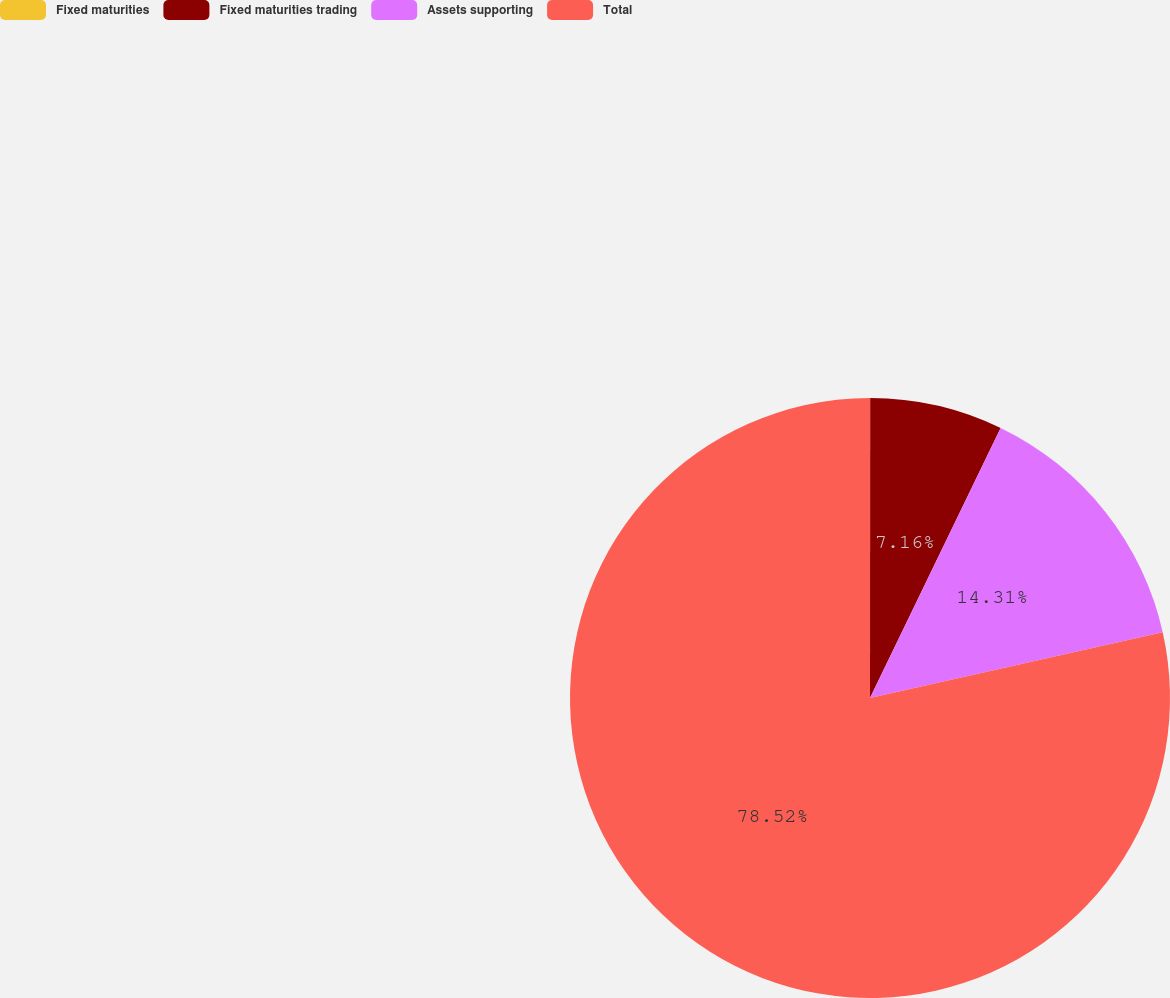<chart> <loc_0><loc_0><loc_500><loc_500><pie_chart><fcel>Fixed maturities<fcel>Fixed maturities trading<fcel>Assets supporting<fcel>Total<nl><fcel>0.01%<fcel>7.16%<fcel>14.31%<fcel>78.52%<nl></chart> 